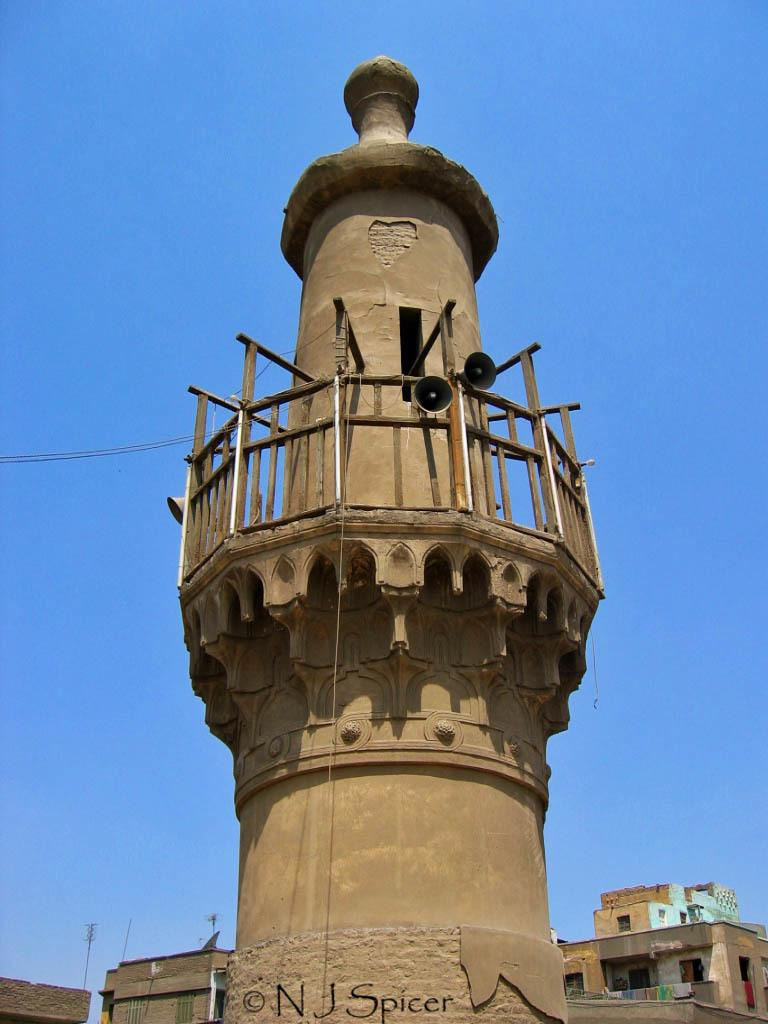What is the main subject of the image? The main subject of the image is a construction site. What can be seen at the bottom of the image? There are houses at the bottom of the image. What objects are located in the middle of the image? There are speakers in the middle of the image. What is visible at the top of the image? The sky is visible at the top of the image. Where is the mailbox located in the image? There is no mailbox present in the image. What type of smoke can be seen coming from the construction site in the image? There is no smoke visible in the image, as it is a construction site and not a source of smoke. 